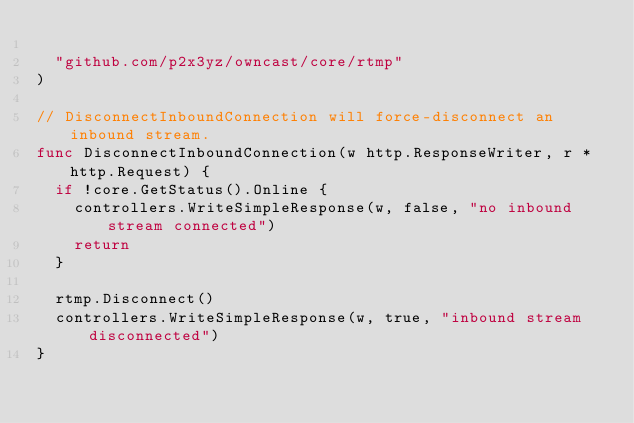<code> <loc_0><loc_0><loc_500><loc_500><_Go_>
	"github.com/p2x3yz/owncast/core/rtmp"
)

// DisconnectInboundConnection will force-disconnect an inbound stream.
func DisconnectInboundConnection(w http.ResponseWriter, r *http.Request) {
	if !core.GetStatus().Online {
		controllers.WriteSimpleResponse(w, false, "no inbound stream connected")
		return
	}

	rtmp.Disconnect()
	controllers.WriteSimpleResponse(w, true, "inbound stream disconnected")
}
</code> 